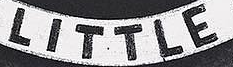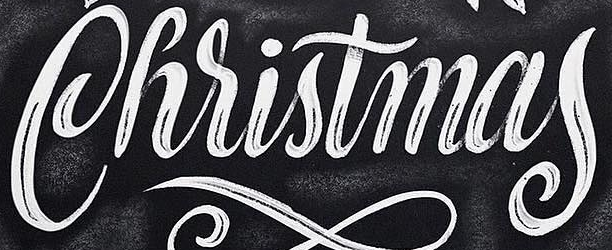Identify the words shown in these images in order, separated by a semicolon. LITTLE; Christmas 